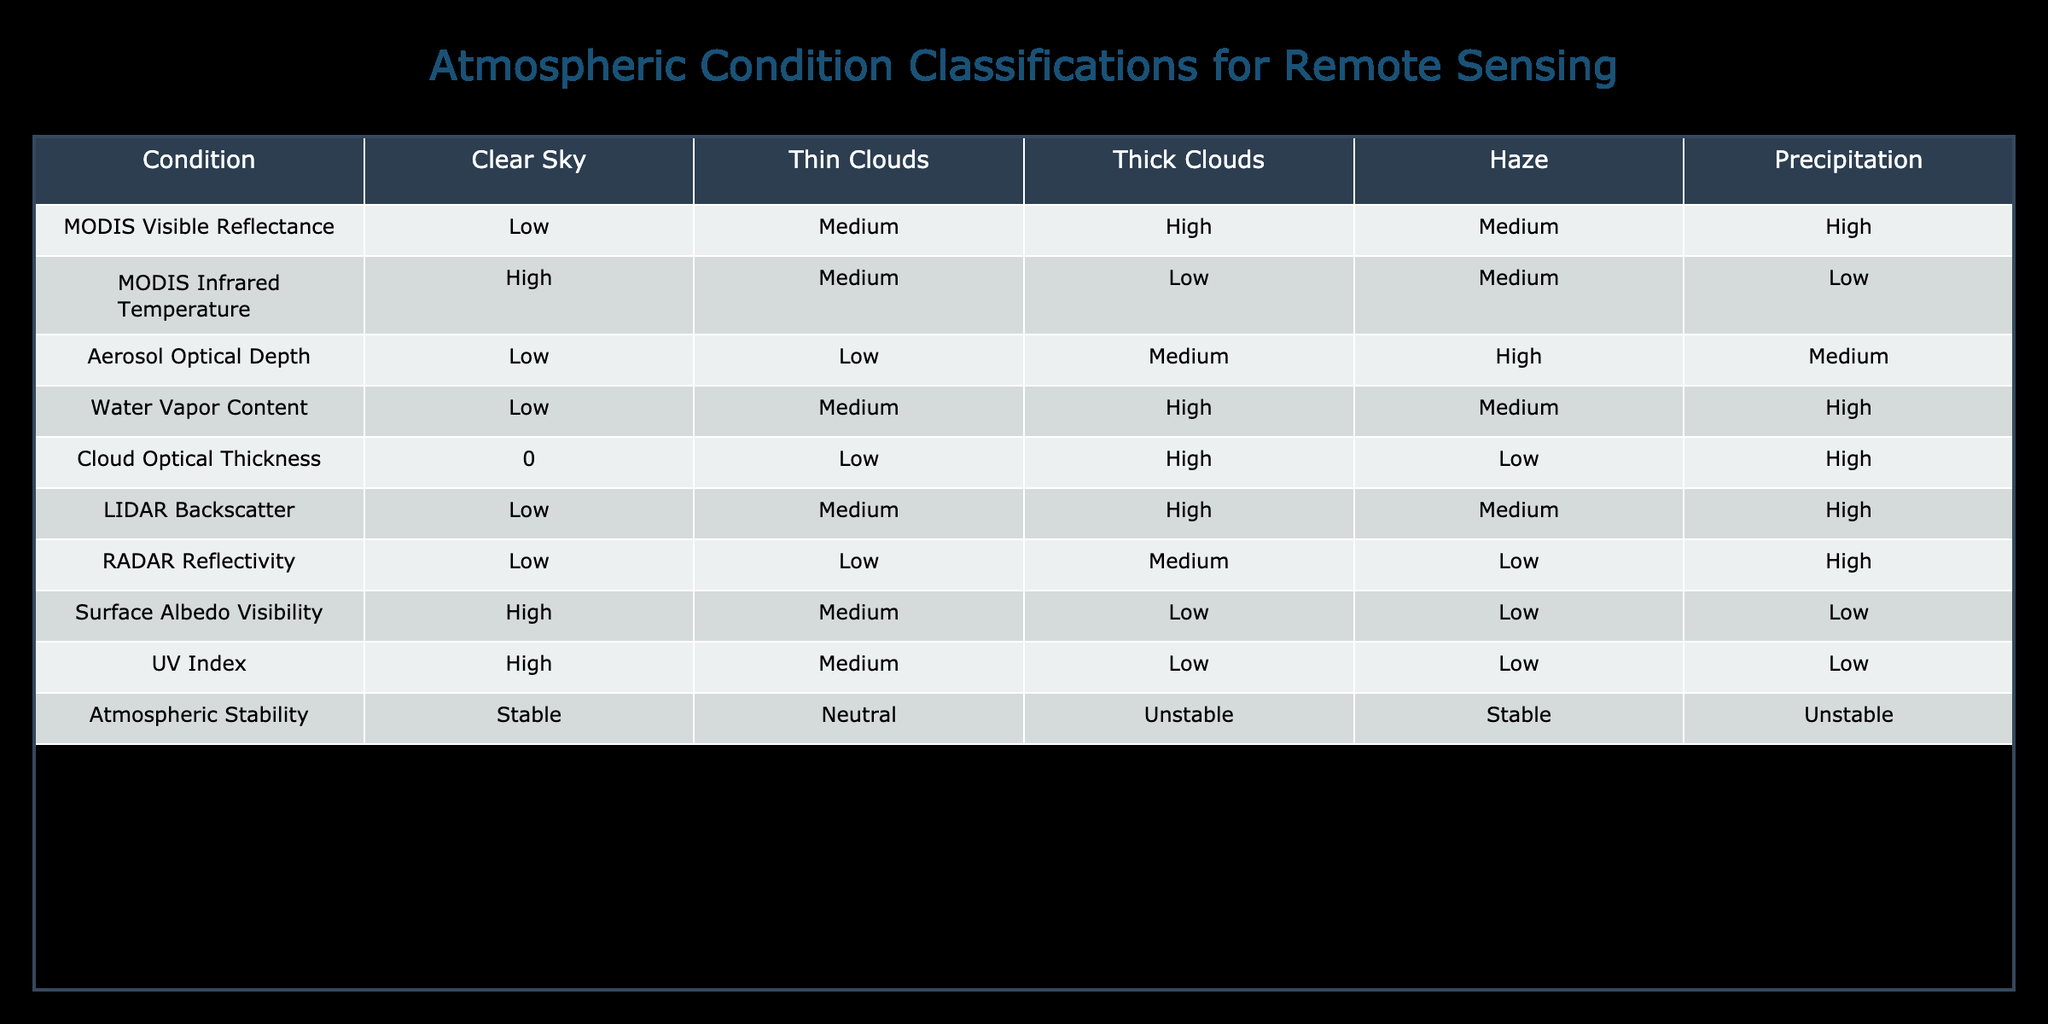What is the MODIS Visible Reflectance value for Thick Clouds? To find the answer, look at the column for MODIS Visible Reflectance and locate the row for Thick Clouds. The table indicates that the value is High.
Answer: High What is the Aerosol Optical Depth for Clear Sky? By referencing the row for Clear Sky under Aerosol Optical Depth, we can see that the value is Low.
Answer: Low Is the Water Vapor Content for Haze greater than that for Clear Sky? For Haze, the Water Vapor Content is Medium, while for Clear Sky, it is Low. Since Medium is greater than Low, the answer is Yes.
Answer: Yes What is the average MODIS Infrared Temperature for Thin Clouds and Haze? The MODIS Infrared Temperature for Thin Clouds is Medium, and for Haze it is Medium as well. To find the average, we convert Medium to a numeric value (assuming Low=1, Medium=2, High=3), resulting in (2 + 2) / 2 = 2, which corresponds to Medium.
Answer: Medium Does the LIDAR Backscatter value indicate Higher intensity for Thick Clouds compared to Clear Sky? The LIDAR Backscatter for Thick Clouds is High while for Clear Sky it is Low. High is greater than Low, hence the statement is true.
Answer: Yes What is the difference in Cloud Optical Thickness between Thick Clouds and Clear Sky? Cloud Optical Thickness for Thick Clouds is High, and for Clear Sky it's 0. Converting these values (assuming 0 for Clear Sky and High=3) gives us a difference of 3 - 0 = 3.
Answer: 3 Which condition has the highest Surface Albedo Visibility, Clear Sky or Haze? Looking at the Surface Albedo Visibility column, Clear Sky has High and Haze has Low. Since High is greater than Low, Clear Sky has the highest value.
Answer: Clear Sky How does Atmospheric Stability compare between Precipitation and Haze? The Atmospheric Stability for Precipitation is Unstable and for Haze it is Stable. Unstable indicates a less stable condition than Stable, thus Precipitation has a lower stability than Haze.
Answer: Haze What is the LIDAR Backscatter value for Haze? By checking the row for Haze under the LIDAR Backscatter column, we find the value is Medium.
Answer: Medium 